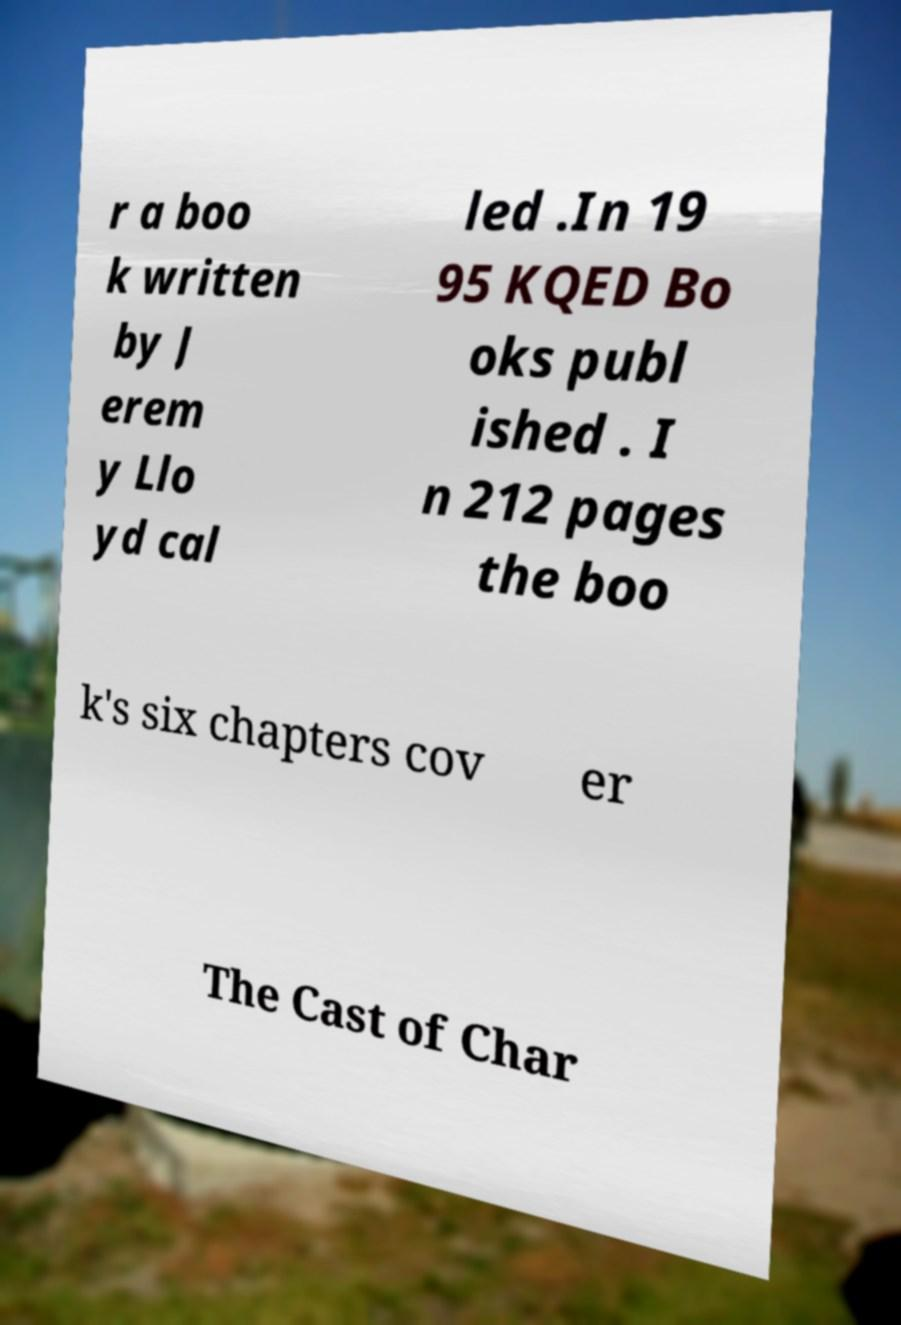For documentation purposes, I need the text within this image transcribed. Could you provide that? r a boo k written by J erem y Llo yd cal led .In 19 95 KQED Bo oks publ ished . I n 212 pages the boo k's six chapters cov er The Cast of Char 